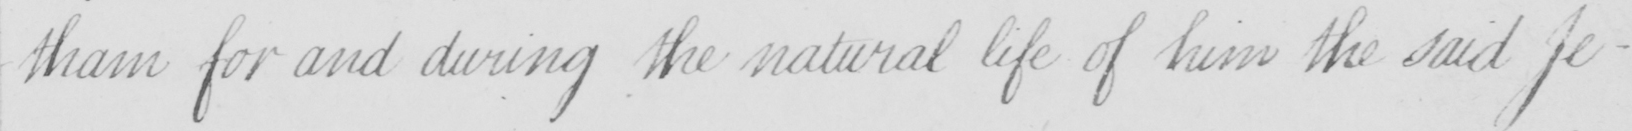Please provide the text content of this handwritten line. -tham for and during the natural life of the said Je- 